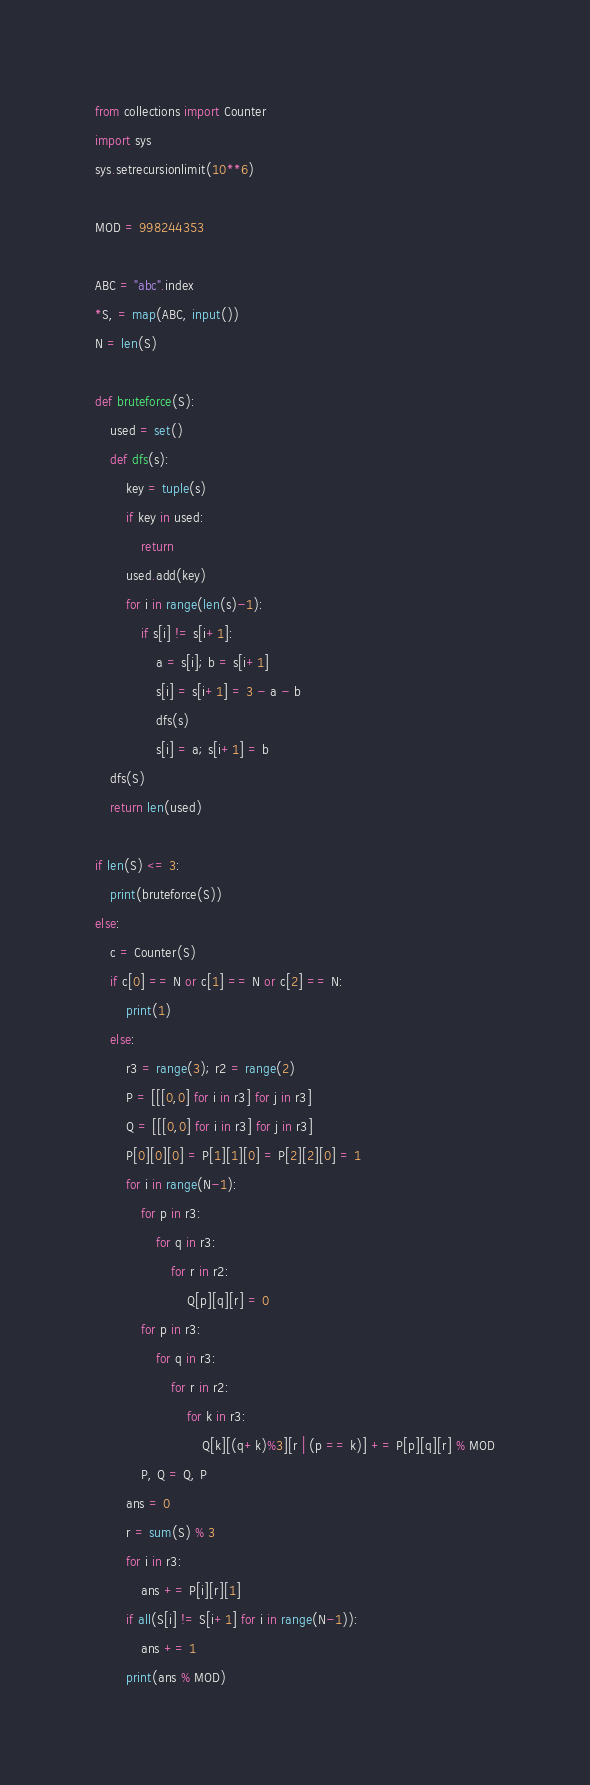<code> <loc_0><loc_0><loc_500><loc_500><_Python_>from collections import Counter
import sys
sys.setrecursionlimit(10**6)

MOD = 998244353

ABC = "abc".index
*S, = map(ABC, input())
N = len(S)

def bruteforce(S):
    used = set()
    def dfs(s):
        key = tuple(s)
        if key in used:
            return
        used.add(key)
        for i in range(len(s)-1):
            if s[i] != s[i+1]:
                a = s[i]; b = s[i+1]
                s[i] = s[i+1] = 3 - a - b
                dfs(s)
                s[i] = a; s[i+1] = b
    dfs(S)
    return len(used)

if len(S) <= 3:
    print(bruteforce(S))
else:
    c = Counter(S)
    if c[0] == N or c[1] == N or c[2] == N:
        print(1)
    else:
        r3 = range(3); r2 = range(2)
        P = [[[0,0] for i in r3] for j in r3]
        Q = [[[0,0] for i in r3] for j in r3]
        P[0][0][0] = P[1][1][0] = P[2][2][0] = 1
        for i in range(N-1):
            for p in r3:
                for q in r3:
                    for r in r2:
                        Q[p][q][r] = 0
            for p in r3:
                for q in r3:
                    for r in r2:
                        for k in r3:
                            Q[k][(q+k)%3][r | (p == k)] += P[p][q][r] % MOD
            P, Q = Q, P
        ans = 0
        r = sum(S) % 3
        for i in r3:
            ans += P[i][r][1]
        if all(S[i] != S[i+1] for i in range(N-1)):
            ans += 1
        print(ans % MOD)</code> 